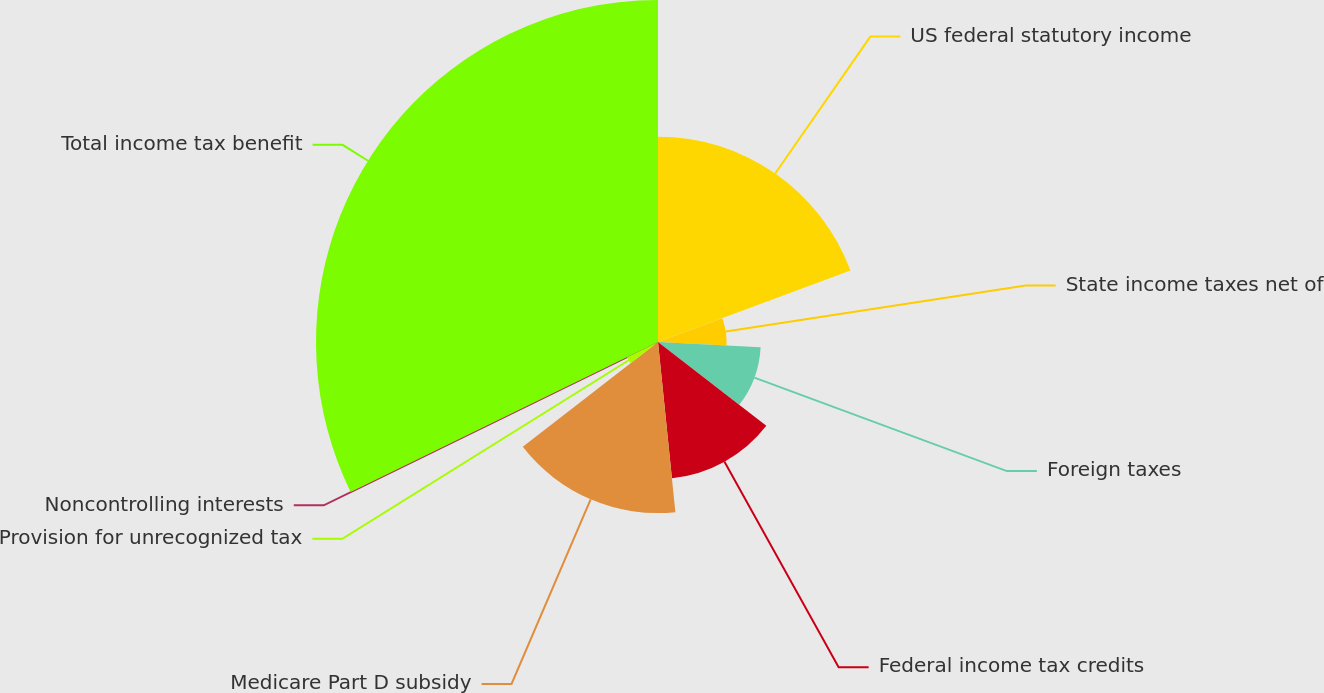Convert chart to OTSL. <chart><loc_0><loc_0><loc_500><loc_500><pie_chart><fcel>US federal statutory income<fcel>State income taxes net of<fcel>Foreign taxes<fcel>Federal income tax credits<fcel>Medicare Part D subsidy<fcel>Provision for unrecognized tax<fcel>Noncontrolling interests<fcel>Total income tax benefit<nl><fcel>19.34%<fcel>6.46%<fcel>9.68%<fcel>12.9%<fcel>16.12%<fcel>3.25%<fcel>0.03%<fcel>32.22%<nl></chart> 